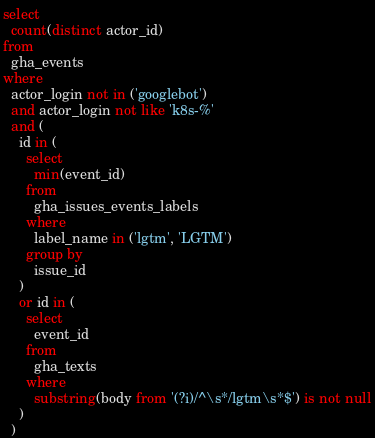Convert code to text. <code><loc_0><loc_0><loc_500><loc_500><_SQL_>select
  count(distinct actor_id)
from
  gha_events
where
  actor_login not in ('googlebot')
  and actor_login not like 'k8s-%'
  and (
    id in (
      select
        min(event_id)
      from
        gha_issues_events_labels
      where
        label_name in ('lgtm', 'LGTM')
      group by
        issue_id
    )
    or id in (
      select
        event_id
      from
        gha_texts
      where
        substring(body from '(?i)/^\s*/lgtm\s*$') is not null
    )
  )
</code> 